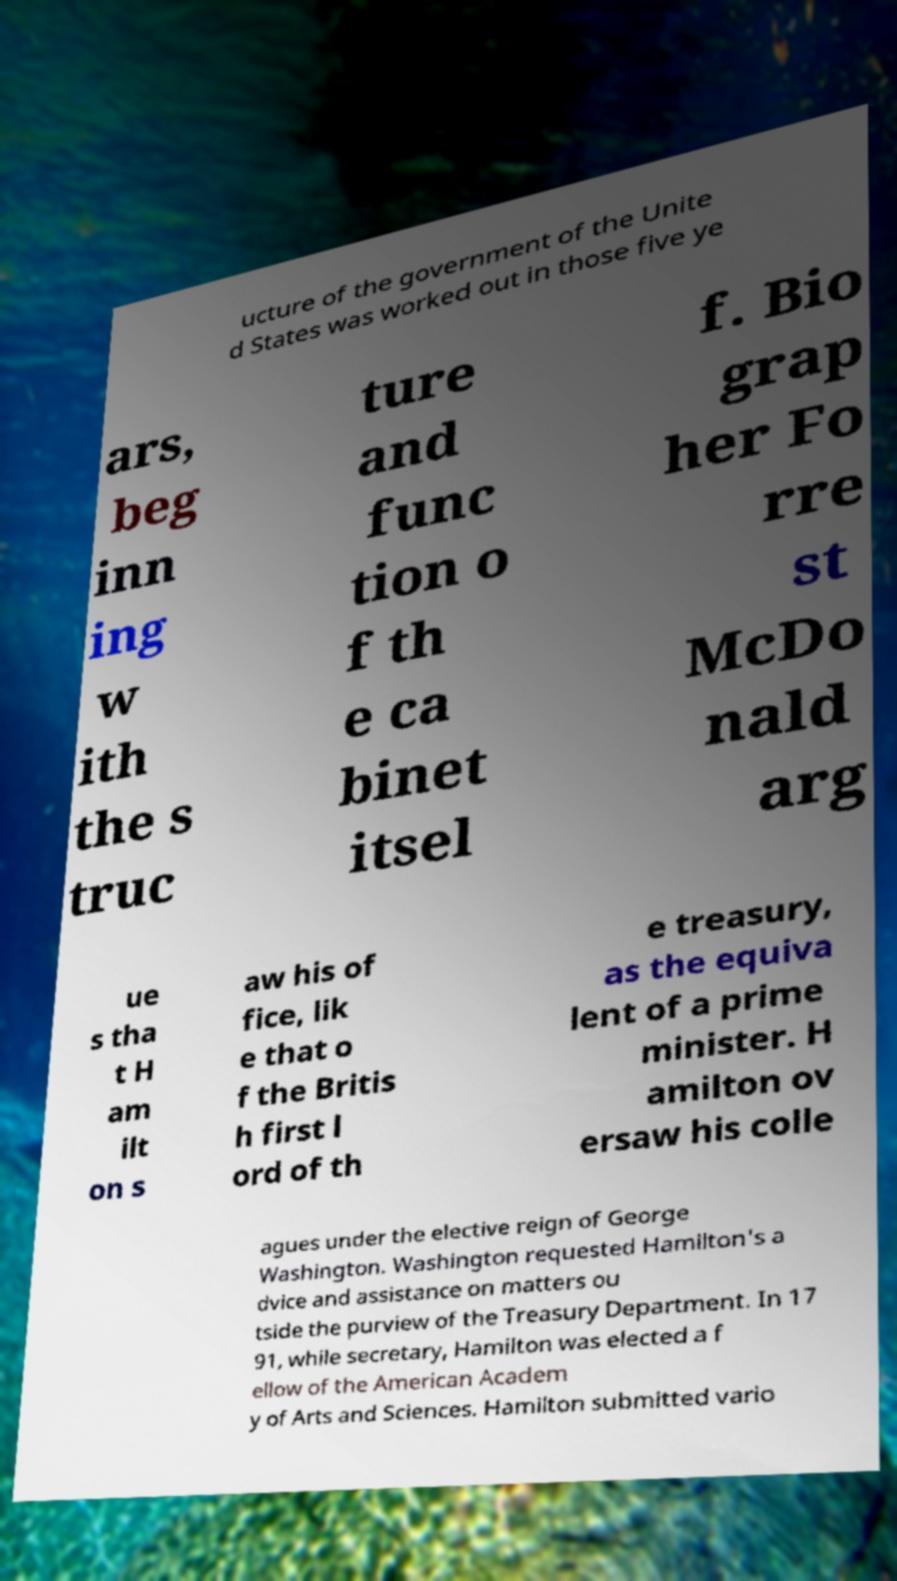Please read and relay the text visible in this image. What does it say? ucture of the government of the Unite d States was worked out in those five ye ars, beg inn ing w ith the s truc ture and func tion o f th e ca binet itsel f. Bio grap her Fo rre st McDo nald arg ue s tha t H am ilt on s aw his of fice, lik e that o f the Britis h first l ord of th e treasury, as the equiva lent of a prime minister. H amilton ov ersaw his colle agues under the elective reign of George Washington. Washington requested Hamilton's a dvice and assistance on matters ou tside the purview of the Treasury Department. In 17 91, while secretary, Hamilton was elected a f ellow of the American Academ y of Arts and Sciences. Hamilton submitted vario 